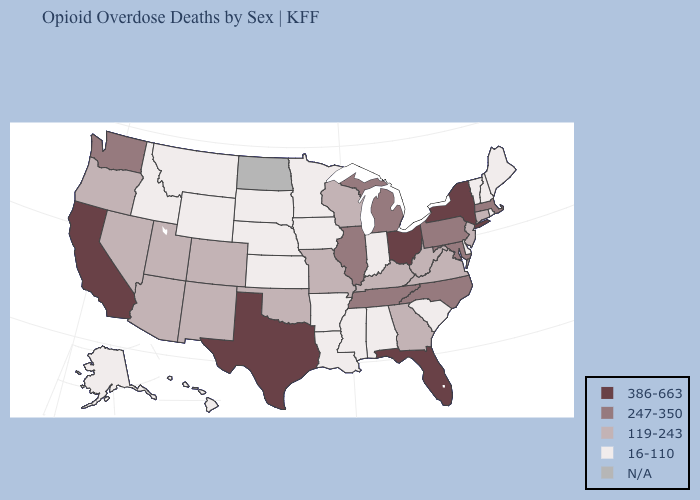Name the states that have a value in the range 16-110?
Concise answer only. Alabama, Alaska, Arkansas, Delaware, Hawaii, Idaho, Indiana, Iowa, Kansas, Louisiana, Maine, Minnesota, Mississippi, Montana, Nebraska, New Hampshire, Rhode Island, South Carolina, South Dakota, Vermont, Wyoming. Among the states that border Oregon , which have the highest value?
Concise answer only. California. Name the states that have a value in the range 119-243?
Write a very short answer. Arizona, Colorado, Connecticut, Georgia, Kentucky, Missouri, Nevada, New Jersey, New Mexico, Oklahoma, Oregon, Utah, Virginia, West Virginia, Wisconsin. Name the states that have a value in the range 247-350?
Keep it brief. Illinois, Maryland, Massachusetts, Michigan, North Carolina, Pennsylvania, Tennessee, Washington. Name the states that have a value in the range 247-350?
Write a very short answer. Illinois, Maryland, Massachusetts, Michigan, North Carolina, Pennsylvania, Tennessee, Washington. Among the states that border New Mexico , which have the highest value?
Answer briefly. Texas. Name the states that have a value in the range 119-243?
Write a very short answer. Arizona, Colorado, Connecticut, Georgia, Kentucky, Missouri, Nevada, New Jersey, New Mexico, Oklahoma, Oregon, Utah, Virginia, West Virginia, Wisconsin. Name the states that have a value in the range 119-243?
Quick response, please. Arizona, Colorado, Connecticut, Georgia, Kentucky, Missouri, Nevada, New Jersey, New Mexico, Oklahoma, Oregon, Utah, Virginia, West Virginia, Wisconsin. Does Idaho have the lowest value in the USA?
Concise answer only. Yes. What is the highest value in states that border Michigan?
Be succinct. 386-663. What is the value of Missouri?
Concise answer only. 119-243. What is the value of New Jersey?
Short answer required. 119-243. Name the states that have a value in the range 386-663?
Write a very short answer. California, Florida, New York, Ohio, Texas. What is the value of Massachusetts?
Keep it brief. 247-350. 